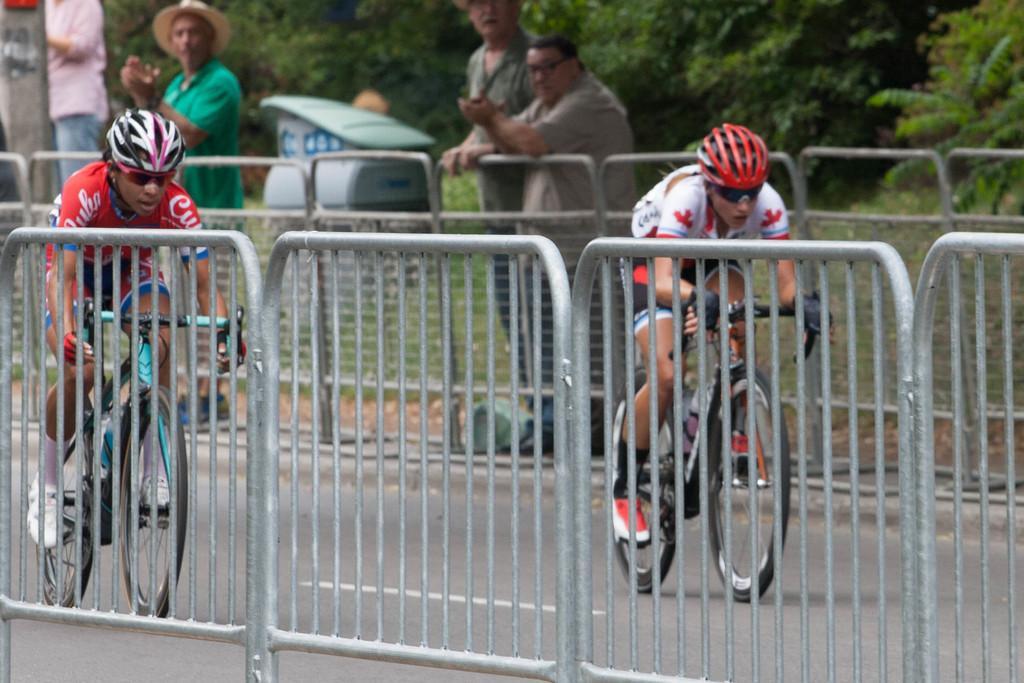Please provide a concise description of this image. In this picture we can see two men wore helmets, goggles, riding bicycles on the road, four people standing, fences, grass, some objects and in the background we can see trees. 